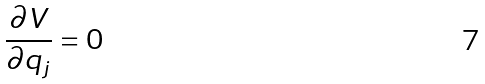<formula> <loc_0><loc_0><loc_500><loc_500>\frac { \partial V } { \partial q _ { j } } = 0</formula> 